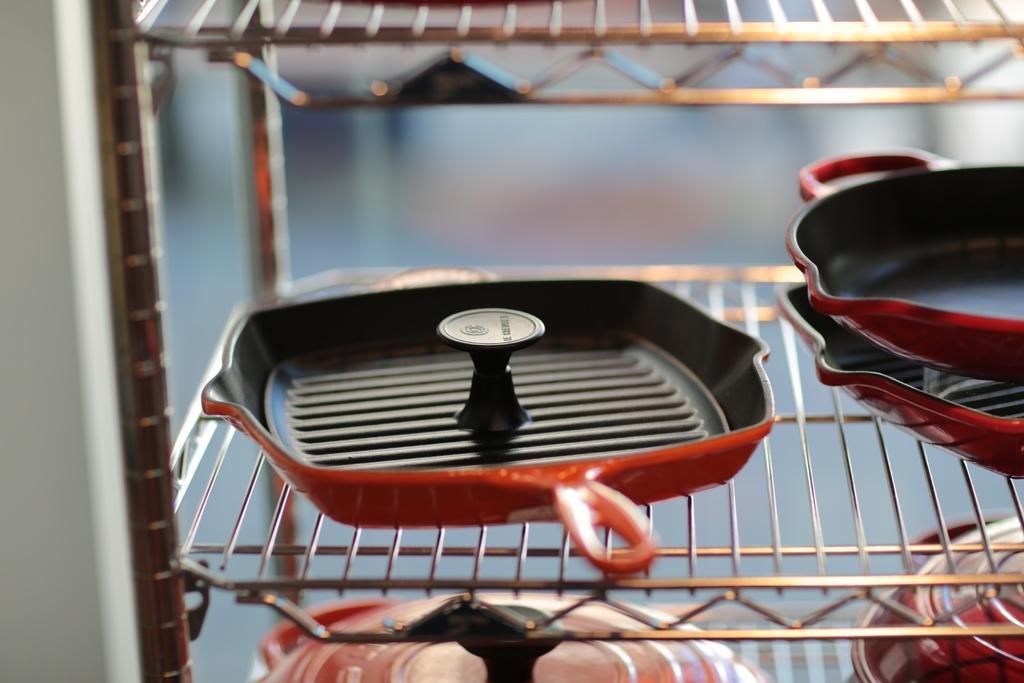Could you give a brief overview of what you see in this image? In the foreground of this image, there are few vessels and pans in the mesh rack and the background image is blurred. 